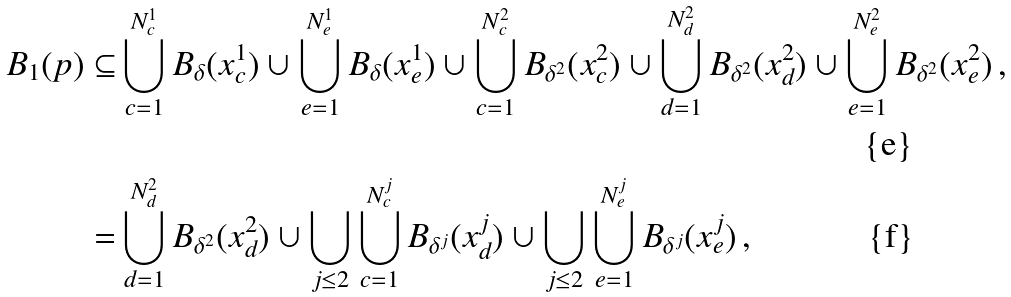Convert formula to latex. <formula><loc_0><loc_0><loc_500><loc_500>B _ { 1 } ( p ) \subseteq & \bigcup _ { c = 1 } ^ { N ^ { 1 } _ { c } } B _ { \delta } ( x ^ { 1 } _ { c } ) \cup \bigcup _ { e = 1 } ^ { N ^ { 1 } _ { e } } B _ { \delta } ( x ^ { 1 } _ { e } ) \cup \bigcup _ { c = 1 } ^ { N ^ { 2 } _ { c } } B _ { \delta ^ { 2 } } ( x ^ { 2 } _ { c } ) \cup \bigcup _ { d = 1 } ^ { N ^ { 2 } _ { d } } B _ { \delta ^ { 2 } } ( x ^ { 2 } _ { d } ) \cup \bigcup _ { e = 1 } ^ { N ^ { 2 } _ { e } } B _ { \delta ^ { 2 } } ( x ^ { 2 } _ { e } ) \, , \\ = & \bigcup _ { d = 1 } ^ { N ^ { 2 } _ { d } } B _ { \delta ^ { 2 } } ( x ^ { 2 } _ { d } ) \cup \bigcup _ { j \leq 2 } \bigcup _ { c = 1 } ^ { N ^ { j } _ { c } } B _ { \delta ^ { j } } ( x ^ { j } _ { d } ) \cup \bigcup _ { j \leq 2 } \bigcup _ { e = 1 } ^ { N ^ { j } _ { e } } B _ { \delta ^ { j } } ( x ^ { j } _ { e } ) \, ,</formula> 